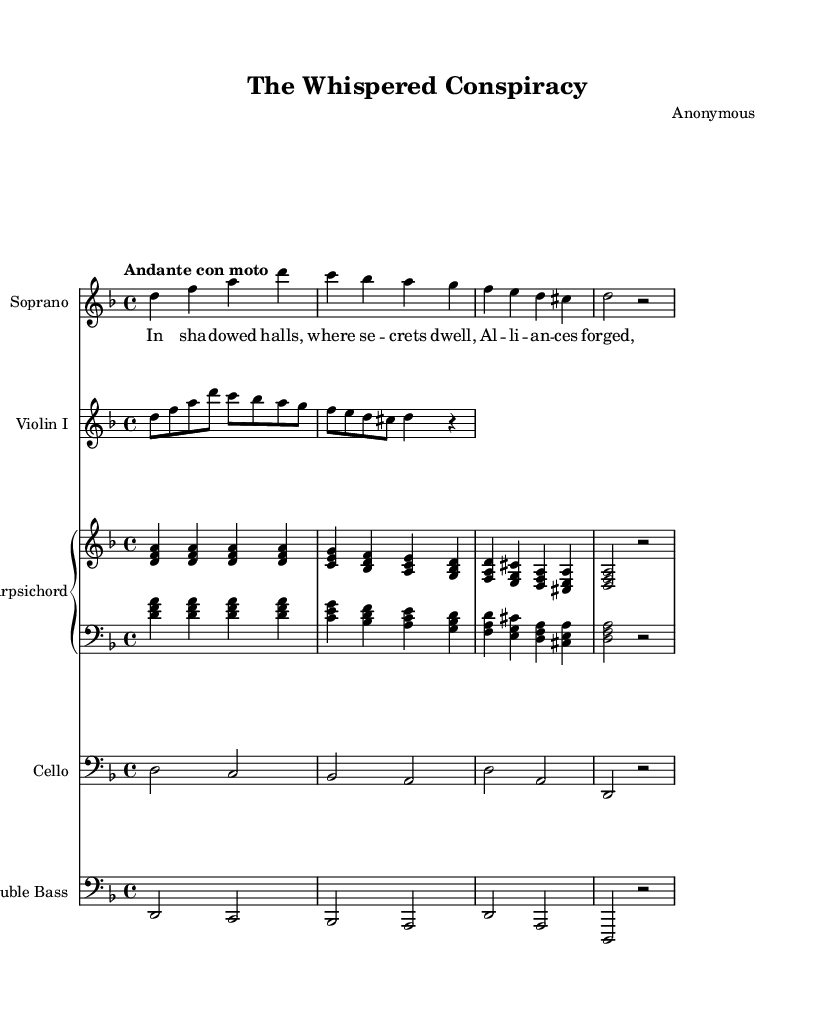What is the key signature of this music? The key signature is indicated by the sharps or flats at the beginning of the staff. Here, there are two flats (B and E) shown, indicating D minor.
Answer: D minor What is the time signature of this music? The time signature can be found at the beginning of the music, represented by two numbers. Here, it shows 4 over 4, which indicates four beats per measure.
Answer: 4/4 What is the tempo of this music? The tempo indication is usually positioned above the staff. In this case, "Andante con moto" is written, suggesting a moderate pace.
Answer: Andante con moto Which instrument has the highest pitch in this score? The highest pitch can typically be found in the soprano line, as it usually carries the lead melody in operas. The music for soprano appears above the other instruments.
Answer: Soprano How many instruments are present in this composition? By counting the distinct staves, we see there are five instrument parts: soprano, violin I, harpsichord, cello, and double bass.
Answer: Five What is the theme of the text in this piece? The lyrics presented provide the narrative context, focusing on secrets, alliances, and power dynamics typical in operas. The content of the lyrics suggests themes of political intrigue.
Answer: Secrets and alliances How does the harmony in the harpsichord part support the narrative? By examining the chords played in the harpsichord part, we can see that it uses triads that create a supporting harmonic structure that emphasizes the emotional tension in the narrative, aligning with the themes of alliances and intrigue.
Answer: Supports intrigue and tension 